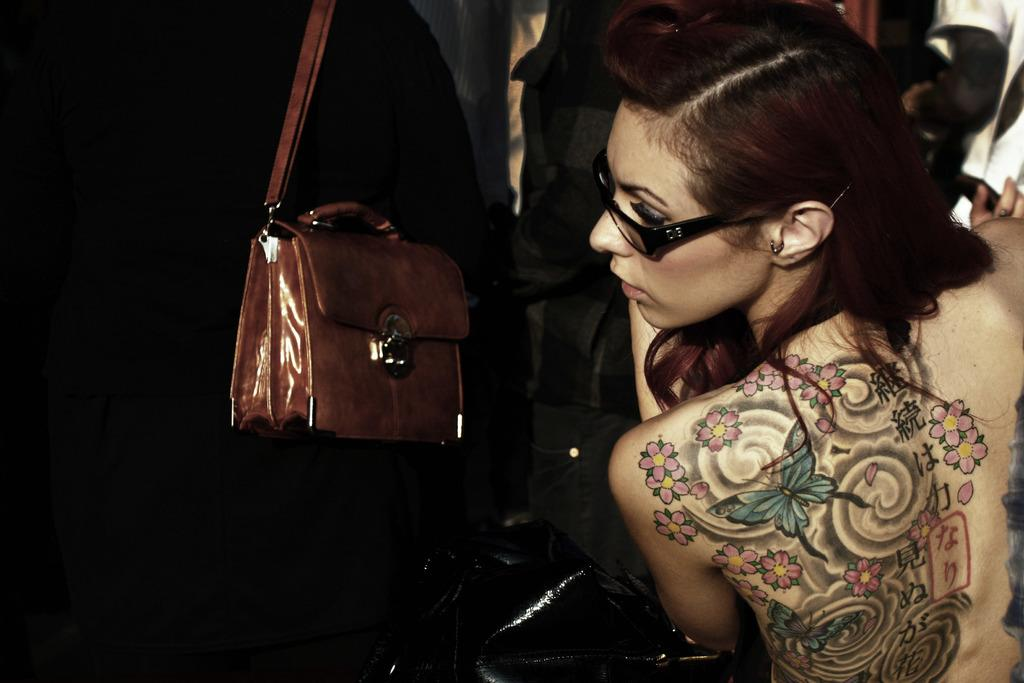Who or what can be seen in the image? There are people in the image. Can you describe the appearance of one of the individuals? A woman is wearing glasses (specs) in the image. What type of accessory is visible in the image? There is a brown-colored handbag in the image. What type of pies are being baked by the people in the image? There is no indication of pies or baking in the image; it only shows people, a woman wearing glasses, and a brown-colored handbag. 